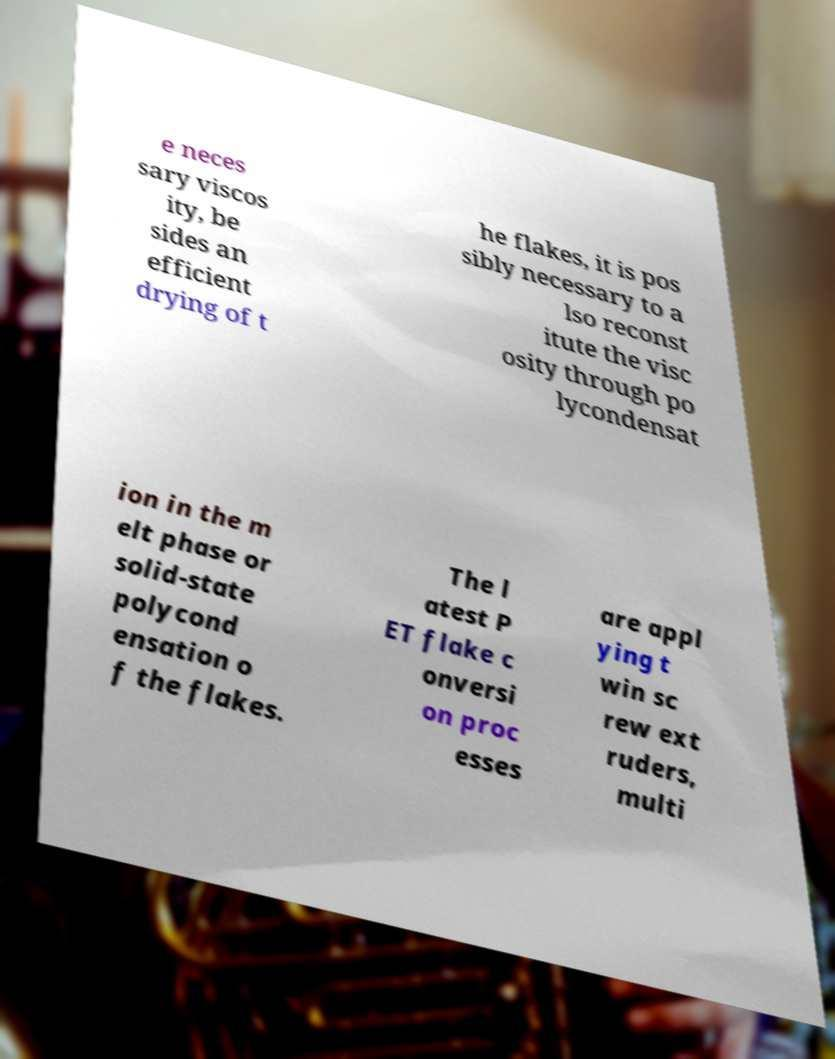Please read and relay the text visible in this image. What does it say? e neces sary viscos ity, be sides an efficient drying of t he flakes, it is pos sibly necessary to a lso reconst itute the visc osity through po lycondensat ion in the m elt phase or solid-state polycond ensation o f the flakes. The l atest P ET flake c onversi on proc esses are appl ying t win sc rew ext ruders, multi 